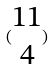Convert formula to latex. <formula><loc_0><loc_0><loc_500><loc_500>( \begin{matrix} 1 1 \\ 4 \end{matrix} )</formula> 